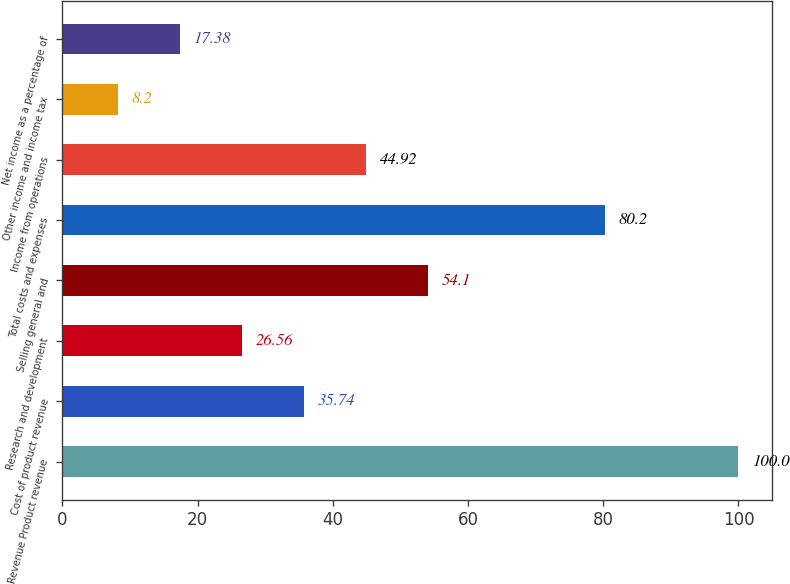Convert chart to OTSL. <chart><loc_0><loc_0><loc_500><loc_500><bar_chart><fcel>Revenue Product revenue<fcel>Cost of product revenue<fcel>Research and development<fcel>Selling general and<fcel>Total costs and expenses<fcel>Income from operations<fcel>Other income and income tax<fcel>Net income as a percentage of<nl><fcel>100<fcel>35.74<fcel>26.56<fcel>54.1<fcel>80.2<fcel>44.92<fcel>8.2<fcel>17.38<nl></chart> 